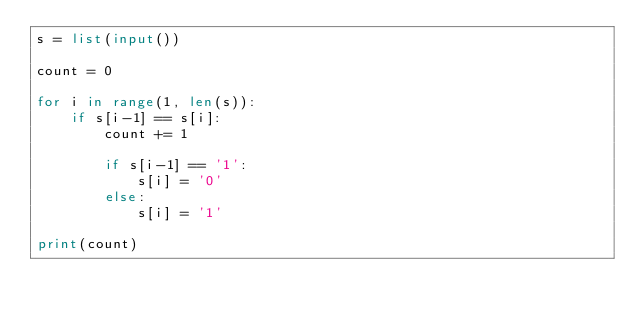Convert code to text. <code><loc_0><loc_0><loc_500><loc_500><_Python_>s = list(input())

count = 0

for i in range(1, len(s)):
    if s[i-1] == s[i]:
        count += 1

        if s[i-1] == '1':
            s[i] = '0'
        else:
            s[i] = '1'

print(count)</code> 